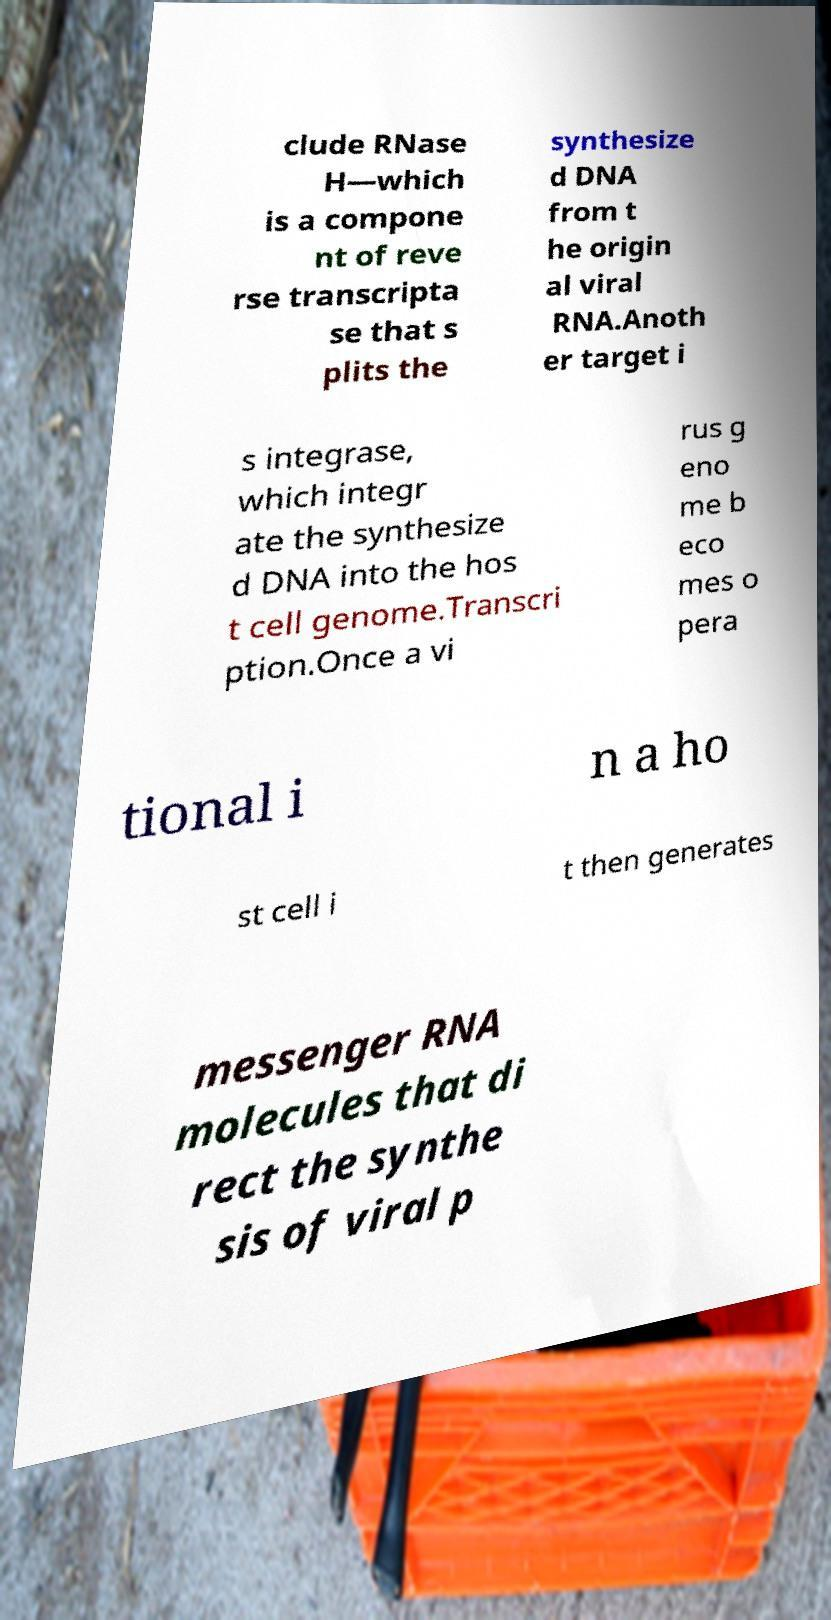Please identify and transcribe the text found in this image. clude RNase H—which is a compone nt of reve rse transcripta se that s plits the synthesize d DNA from t he origin al viral RNA.Anoth er target i s integrase, which integr ate the synthesize d DNA into the hos t cell genome.Transcri ption.Once a vi rus g eno me b eco mes o pera tional i n a ho st cell i t then generates messenger RNA molecules that di rect the synthe sis of viral p 